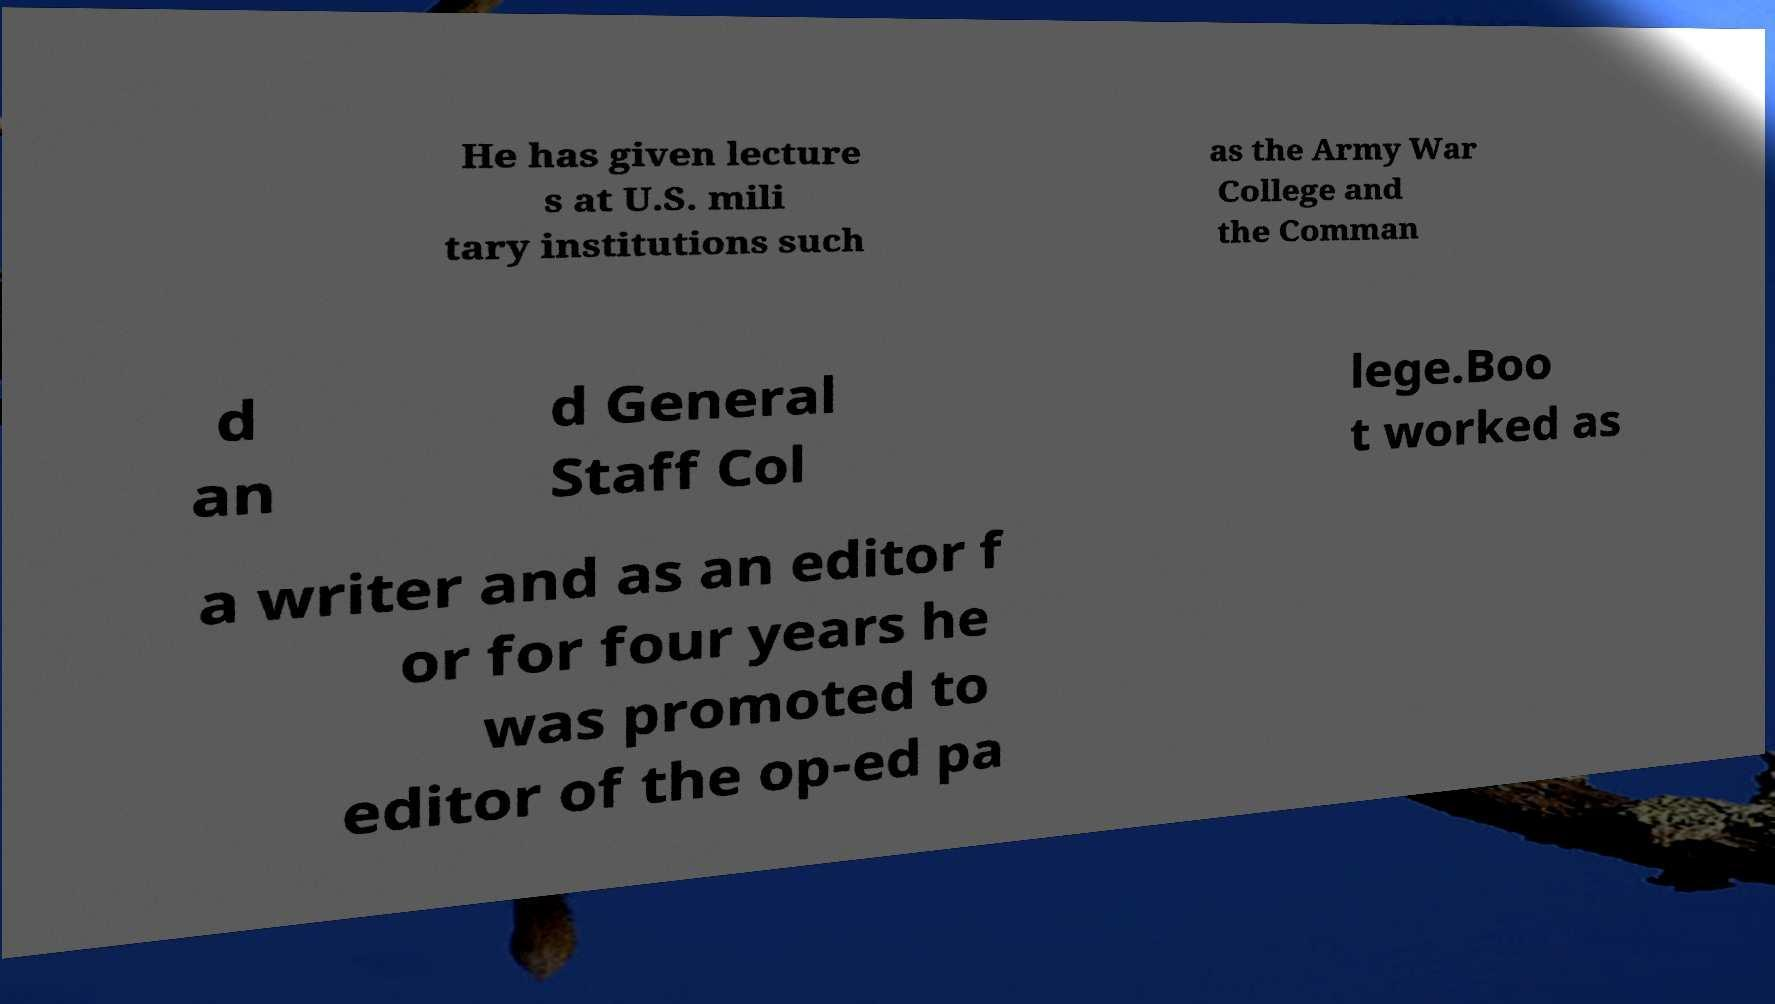I need the written content from this picture converted into text. Can you do that? He has given lecture s at U.S. mili tary institutions such as the Army War College and the Comman d an d General Staff Col lege.Boo t worked as a writer and as an editor f or for four years he was promoted to editor of the op-ed pa 